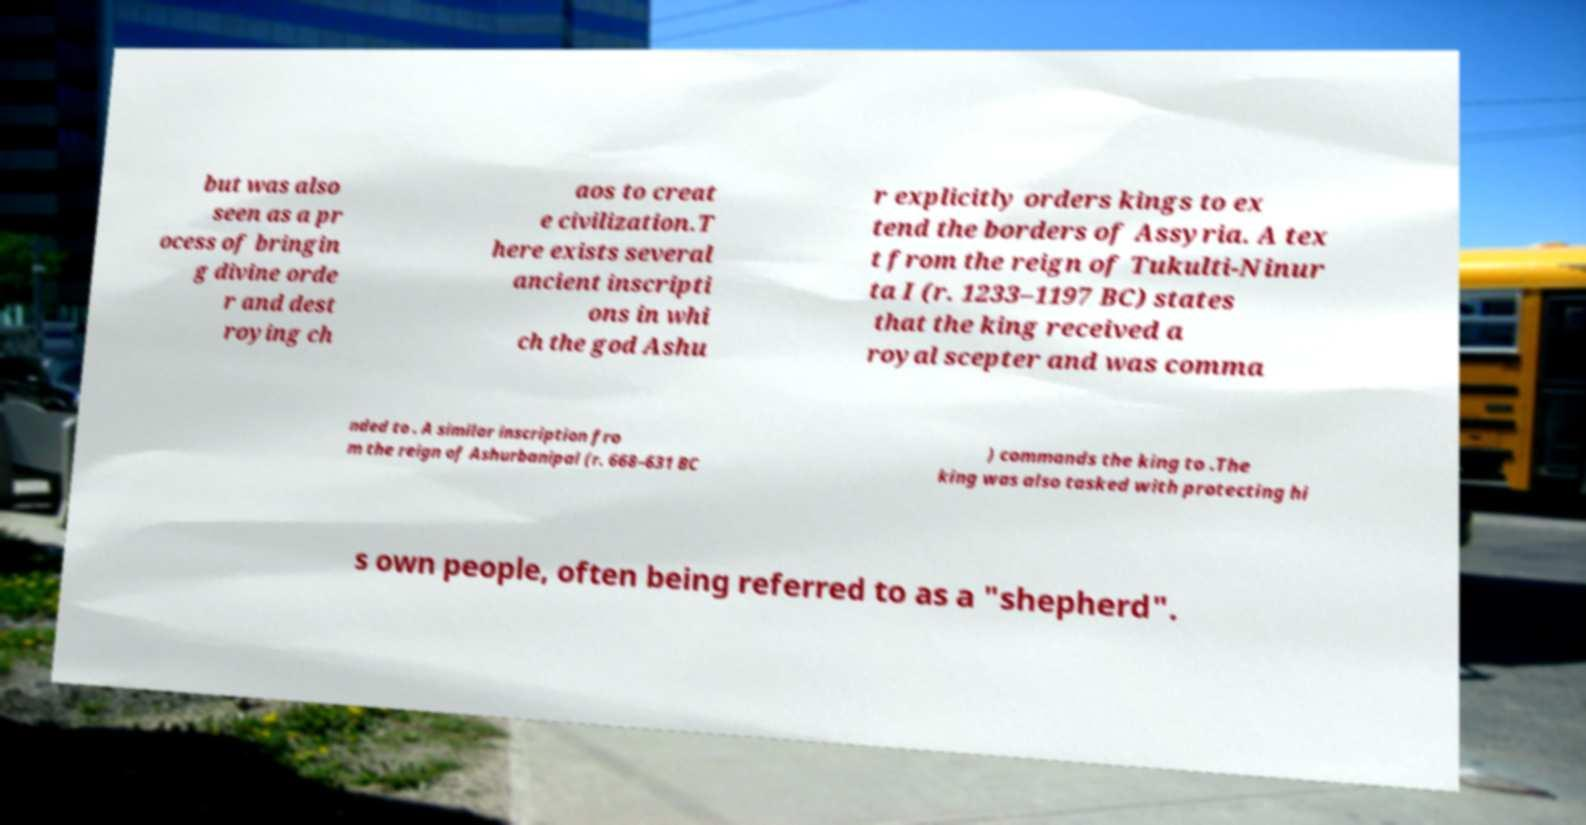I need the written content from this picture converted into text. Can you do that? but was also seen as a pr ocess of bringin g divine orde r and dest roying ch aos to creat e civilization.T here exists several ancient inscripti ons in whi ch the god Ashu r explicitly orders kings to ex tend the borders of Assyria. A tex t from the reign of Tukulti-Ninur ta I (r. 1233–1197 BC) states that the king received a royal scepter and was comma nded to . A similar inscription fro m the reign of Ashurbanipal (r. 668–631 BC ) commands the king to .The king was also tasked with protecting hi s own people, often being referred to as a "shepherd". 